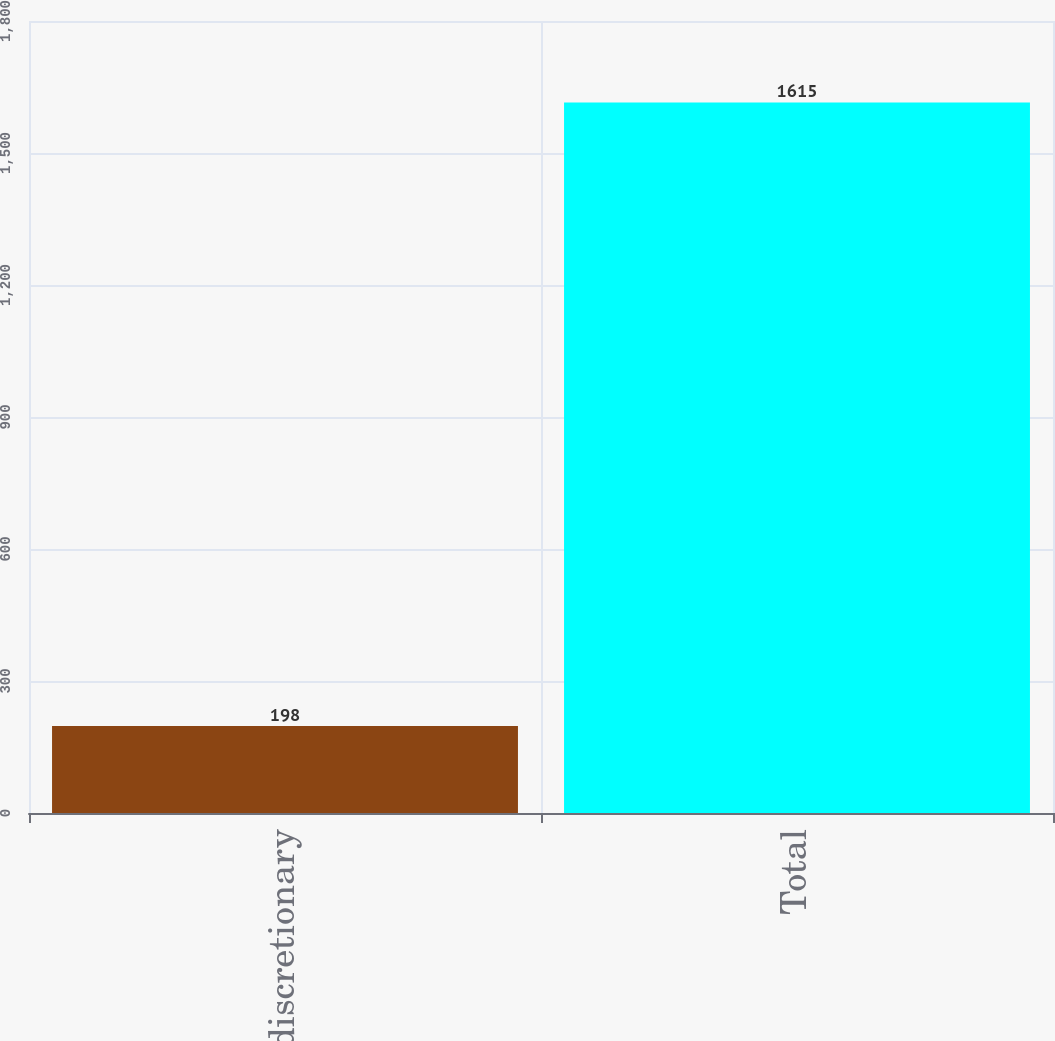<chart> <loc_0><loc_0><loc_500><loc_500><bar_chart><fcel>Non-discretionary<fcel>Total<nl><fcel>198<fcel>1615<nl></chart> 